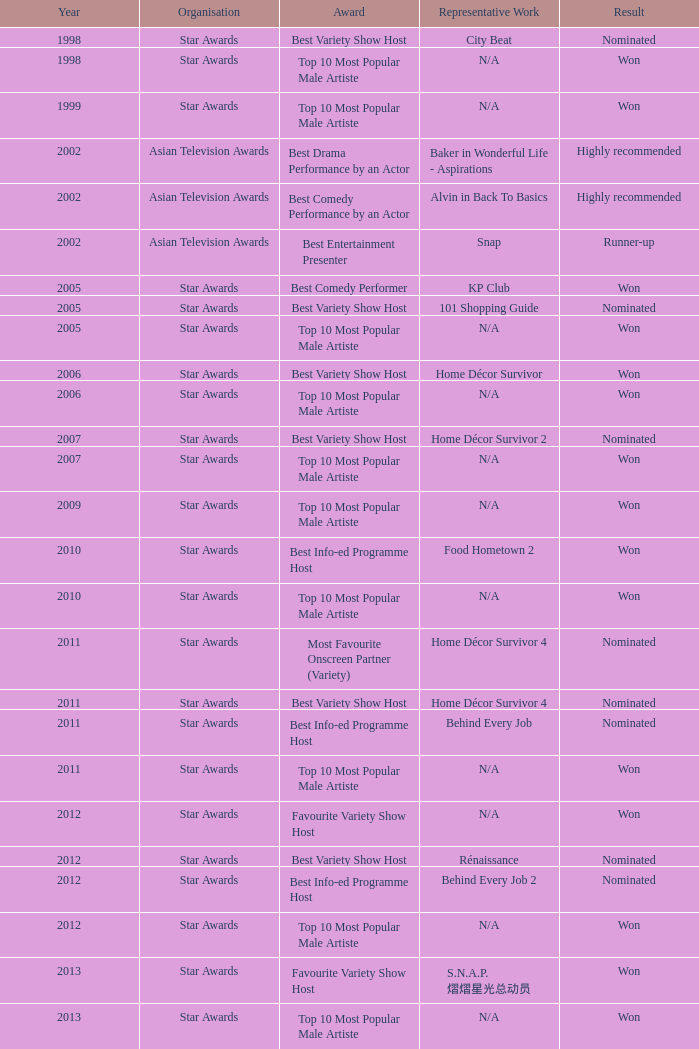What is the award for the Star Awards earlier than 2005 and the result is won? Top 10 Most Popular Male Artiste, Top 10 Most Popular Male Artiste. 